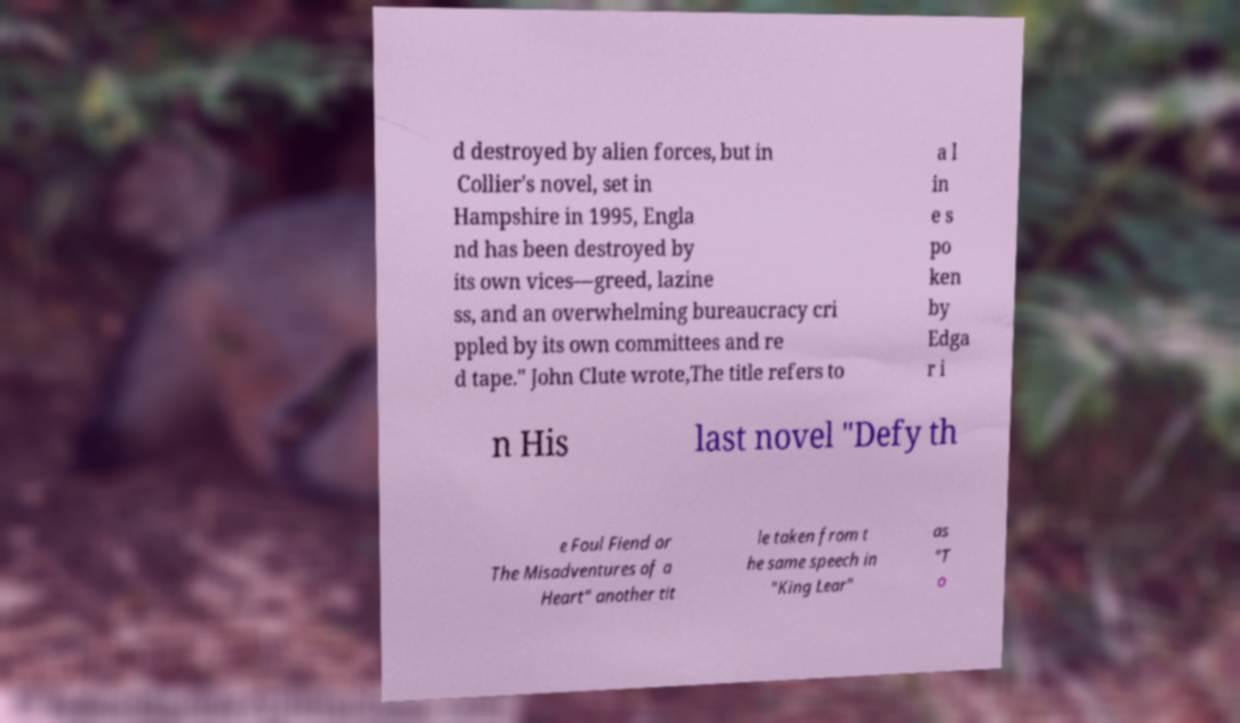Please identify and transcribe the text found in this image. d destroyed by alien forces, but in Collier's novel, set in Hampshire in 1995, Engla nd has been destroyed by its own vices—greed, lazine ss, and an overwhelming bureaucracy cri ppled by its own committees and re d tape." John Clute wrote,The title refers to a l in e s po ken by Edga r i n His last novel "Defy th e Foul Fiend or The Misadventures of a Heart" another tit le taken from t he same speech in "King Lear" as "T o 